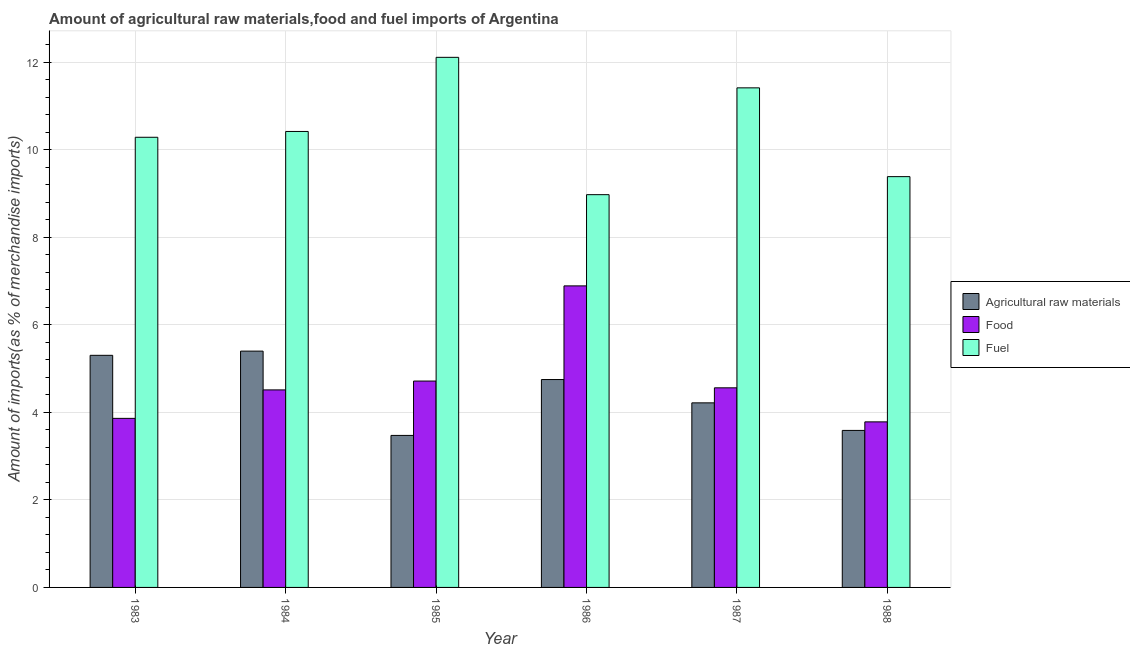Are the number of bars per tick equal to the number of legend labels?
Make the answer very short. Yes. Are the number of bars on each tick of the X-axis equal?
Give a very brief answer. Yes. How many bars are there on the 5th tick from the left?
Keep it short and to the point. 3. What is the percentage of food imports in 1983?
Provide a short and direct response. 3.86. Across all years, what is the maximum percentage of raw materials imports?
Offer a very short reply. 5.4. Across all years, what is the minimum percentage of fuel imports?
Offer a very short reply. 8.98. In which year was the percentage of fuel imports maximum?
Make the answer very short. 1985. What is the total percentage of fuel imports in the graph?
Offer a very short reply. 62.61. What is the difference between the percentage of fuel imports in 1987 and that in 1988?
Give a very brief answer. 2.03. What is the difference between the percentage of fuel imports in 1983 and the percentage of raw materials imports in 1986?
Provide a short and direct response. 1.31. What is the average percentage of raw materials imports per year?
Make the answer very short. 4.46. In the year 1984, what is the difference between the percentage of raw materials imports and percentage of food imports?
Ensure brevity in your answer.  0. What is the ratio of the percentage of food imports in 1983 to that in 1985?
Keep it short and to the point. 0.82. What is the difference between the highest and the second highest percentage of fuel imports?
Keep it short and to the point. 0.7. What is the difference between the highest and the lowest percentage of fuel imports?
Provide a succinct answer. 3.14. In how many years, is the percentage of food imports greater than the average percentage of food imports taken over all years?
Offer a terse response. 1. Is the sum of the percentage of food imports in 1984 and 1988 greater than the maximum percentage of fuel imports across all years?
Provide a succinct answer. Yes. What does the 1st bar from the left in 1986 represents?
Your response must be concise. Agricultural raw materials. What does the 1st bar from the right in 1988 represents?
Provide a short and direct response. Fuel. What is the difference between two consecutive major ticks on the Y-axis?
Your answer should be compact. 2. Are the values on the major ticks of Y-axis written in scientific E-notation?
Ensure brevity in your answer.  No. Does the graph contain any zero values?
Provide a succinct answer. No. Does the graph contain grids?
Make the answer very short. Yes. Where does the legend appear in the graph?
Your answer should be compact. Center right. How many legend labels are there?
Offer a terse response. 3. What is the title of the graph?
Provide a succinct answer. Amount of agricultural raw materials,food and fuel imports of Argentina. Does "Natural Gas" appear as one of the legend labels in the graph?
Keep it short and to the point. No. What is the label or title of the X-axis?
Your response must be concise. Year. What is the label or title of the Y-axis?
Offer a terse response. Amount of imports(as % of merchandise imports). What is the Amount of imports(as % of merchandise imports) in Agricultural raw materials in 1983?
Your answer should be very brief. 5.3. What is the Amount of imports(as % of merchandise imports) of Food in 1983?
Make the answer very short. 3.86. What is the Amount of imports(as % of merchandise imports) of Fuel in 1983?
Give a very brief answer. 10.29. What is the Amount of imports(as % of merchandise imports) in Agricultural raw materials in 1984?
Provide a succinct answer. 5.4. What is the Amount of imports(as % of merchandise imports) of Food in 1984?
Your answer should be compact. 4.51. What is the Amount of imports(as % of merchandise imports) of Fuel in 1984?
Make the answer very short. 10.42. What is the Amount of imports(as % of merchandise imports) in Agricultural raw materials in 1985?
Give a very brief answer. 3.47. What is the Amount of imports(as % of merchandise imports) of Food in 1985?
Provide a succinct answer. 4.72. What is the Amount of imports(as % of merchandise imports) of Fuel in 1985?
Provide a succinct answer. 12.12. What is the Amount of imports(as % of merchandise imports) in Agricultural raw materials in 1986?
Your response must be concise. 4.75. What is the Amount of imports(as % of merchandise imports) of Food in 1986?
Ensure brevity in your answer.  6.89. What is the Amount of imports(as % of merchandise imports) of Fuel in 1986?
Your answer should be compact. 8.98. What is the Amount of imports(as % of merchandise imports) of Agricultural raw materials in 1987?
Your answer should be compact. 4.22. What is the Amount of imports(as % of merchandise imports) of Food in 1987?
Offer a very short reply. 4.56. What is the Amount of imports(as % of merchandise imports) of Fuel in 1987?
Keep it short and to the point. 11.42. What is the Amount of imports(as % of merchandise imports) of Agricultural raw materials in 1988?
Your answer should be compact. 3.59. What is the Amount of imports(as % of merchandise imports) in Food in 1988?
Offer a terse response. 3.78. What is the Amount of imports(as % of merchandise imports) of Fuel in 1988?
Ensure brevity in your answer.  9.39. Across all years, what is the maximum Amount of imports(as % of merchandise imports) of Agricultural raw materials?
Offer a very short reply. 5.4. Across all years, what is the maximum Amount of imports(as % of merchandise imports) in Food?
Your response must be concise. 6.89. Across all years, what is the maximum Amount of imports(as % of merchandise imports) of Fuel?
Make the answer very short. 12.12. Across all years, what is the minimum Amount of imports(as % of merchandise imports) in Agricultural raw materials?
Provide a short and direct response. 3.47. Across all years, what is the minimum Amount of imports(as % of merchandise imports) of Food?
Your response must be concise. 3.78. Across all years, what is the minimum Amount of imports(as % of merchandise imports) of Fuel?
Your answer should be compact. 8.98. What is the total Amount of imports(as % of merchandise imports) in Agricultural raw materials in the graph?
Keep it short and to the point. 26.74. What is the total Amount of imports(as % of merchandise imports) in Food in the graph?
Give a very brief answer. 28.33. What is the total Amount of imports(as % of merchandise imports) of Fuel in the graph?
Give a very brief answer. 62.61. What is the difference between the Amount of imports(as % of merchandise imports) of Agricultural raw materials in 1983 and that in 1984?
Give a very brief answer. -0.1. What is the difference between the Amount of imports(as % of merchandise imports) in Food in 1983 and that in 1984?
Keep it short and to the point. -0.65. What is the difference between the Amount of imports(as % of merchandise imports) of Fuel in 1983 and that in 1984?
Provide a succinct answer. -0.13. What is the difference between the Amount of imports(as % of merchandise imports) in Agricultural raw materials in 1983 and that in 1985?
Your answer should be compact. 1.83. What is the difference between the Amount of imports(as % of merchandise imports) in Food in 1983 and that in 1985?
Provide a succinct answer. -0.85. What is the difference between the Amount of imports(as % of merchandise imports) in Fuel in 1983 and that in 1985?
Make the answer very short. -1.83. What is the difference between the Amount of imports(as % of merchandise imports) of Agricultural raw materials in 1983 and that in 1986?
Your answer should be very brief. 0.55. What is the difference between the Amount of imports(as % of merchandise imports) of Food in 1983 and that in 1986?
Your answer should be very brief. -3.03. What is the difference between the Amount of imports(as % of merchandise imports) of Fuel in 1983 and that in 1986?
Your response must be concise. 1.31. What is the difference between the Amount of imports(as % of merchandise imports) in Agricultural raw materials in 1983 and that in 1987?
Your answer should be compact. 1.09. What is the difference between the Amount of imports(as % of merchandise imports) of Food in 1983 and that in 1987?
Make the answer very short. -0.7. What is the difference between the Amount of imports(as % of merchandise imports) of Fuel in 1983 and that in 1987?
Keep it short and to the point. -1.13. What is the difference between the Amount of imports(as % of merchandise imports) of Agricultural raw materials in 1983 and that in 1988?
Provide a short and direct response. 1.72. What is the difference between the Amount of imports(as % of merchandise imports) in Food in 1983 and that in 1988?
Your response must be concise. 0.08. What is the difference between the Amount of imports(as % of merchandise imports) in Fuel in 1983 and that in 1988?
Ensure brevity in your answer.  0.9. What is the difference between the Amount of imports(as % of merchandise imports) of Agricultural raw materials in 1984 and that in 1985?
Your answer should be compact. 1.93. What is the difference between the Amount of imports(as % of merchandise imports) in Food in 1984 and that in 1985?
Keep it short and to the point. -0.2. What is the difference between the Amount of imports(as % of merchandise imports) of Fuel in 1984 and that in 1985?
Provide a short and direct response. -1.69. What is the difference between the Amount of imports(as % of merchandise imports) of Agricultural raw materials in 1984 and that in 1986?
Make the answer very short. 0.65. What is the difference between the Amount of imports(as % of merchandise imports) in Food in 1984 and that in 1986?
Your answer should be compact. -2.38. What is the difference between the Amount of imports(as % of merchandise imports) in Fuel in 1984 and that in 1986?
Your answer should be very brief. 1.44. What is the difference between the Amount of imports(as % of merchandise imports) in Agricultural raw materials in 1984 and that in 1987?
Offer a very short reply. 1.18. What is the difference between the Amount of imports(as % of merchandise imports) in Food in 1984 and that in 1987?
Your answer should be very brief. -0.05. What is the difference between the Amount of imports(as % of merchandise imports) in Fuel in 1984 and that in 1987?
Provide a succinct answer. -1. What is the difference between the Amount of imports(as % of merchandise imports) of Agricultural raw materials in 1984 and that in 1988?
Give a very brief answer. 1.81. What is the difference between the Amount of imports(as % of merchandise imports) of Food in 1984 and that in 1988?
Offer a terse response. 0.73. What is the difference between the Amount of imports(as % of merchandise imports) of Fuel in 1984 and that in 1988?
Provide a succinct answer. 1.03. What is the difference between the Amount of imports(as % of merchandise imports) of Agricultural raw materials in 1985 and that in 1986?
Provide a succinct answer. -1.28. What is the difference between the Amount of imports(as % of merchandise imports) in Food in 1985 and that in 1986?
Offer a very short reply. -2.18. What is the difference between the Amount of imports(as % of merchandise imports) in Fuel in 1985 and that in 1986?
Your response must be concise. 3.14. What is the difference between the Amount of imports(as % of merchandise imports) in Agricultural raw materials in 1985 and that in 1987?
Give a very brief answer. -0.74. What is the difference between the Amount of imports(as % of merchandise imports) in Food in 1985 and that in 1987?
Offer a terse response. 0.15. What is the difference between the Amount of imports(as % of merchandise imports) in Fuel in 1985 and that in 1987?
Your response must be concise. 0.7. What is the difference between the Amount of imports(as % of merchandise imports) of Agricultural raw materials in 1985 and that in 1988?
Offer a very short reply. -0.11. What is the difference between the Amount of imports(as % of merchandise imports) in Food in 1985 and that in 1988?
Make the answer very short. 0.93. What is the difference between the Amount of imports(as % of merchandise imports) of Fuel in 1985 and that in 1988?
Offer a terse response. 2.73. What is the difference between the Amount of imports(as % of merchandise imports) in Agricultural raw materials in 1986 and that in 1987?
Give a very brief answer. 0.53. What is the difference between the Amount of imports(as % of merchandise imports) of Food in 1986 and that in 1987?
Your response must be concise. 2.33. What is the difference between the Amount of imports(as % of merchandise imports) of Fuel in 1986 and that in 1987?
Your response must be concise. -2.44. What is the difference between the Amount of imports(as % of merchandise imports) of Agricultural raw materials in 1986 and that in 1988?
Your answer should be very brief. 1.16. What is the difference between the Amount of imports(as % of merchandise imports) of Food in 1986 and that in 1988?
Ensure brevity in your answer.  3.11. What is the difference between the Amount of imports(as % of merchandise imports) in Fuel in 1986 and that in 1988?
Offer a very short reply. -0.41. What is the difference between the Amount of imports(as % of merchandise imports) of Agricultural raw materials in 1987 and that in 1988?
Provide a succinct answer. 0.63. What is the difference between the Amount of imports(as % of merchandise imports) in Food in 1987 and that in 1988?
Provide a short and direct response. 0.78. What is the difference between the Amount of imports(as % of merchandise imports) in Fuel in 1987 and that in 1988?
Provide a short and direct response. 2.03. What is the difference between the Amount of imports(as % of merchandise imports) in Agricultural raw materials in 1983 and the Amount of imports(as % of merchandise imports) in Food in 1984?
Your answer should be compact. 0.79. What is the difference between the Amount of imports(as % of merchandise imports) in Agricultural raw materials in 1983 and the Amount of imports(as % of merchandise imports) in Fuel in 1984?
Provide a succinct answer. -5.12. What is the difference between the Amount of imports(as % of merchandise imports) of Food in 1983 and the Amount of imports(as % of merchandise imports) of Fuel in 1984?
Make the answer very short. -6.56. What is the difference between the Amount of imports(as % of merchandise imports) of Agricultural raw materials in 1983 and the Amount of imports(as % of merchandise imports) of Food in 1985?
Your response must be concise. 0.59. What is the difference between the Amount of imports(as % of merchandise imports) in Agricultural raw materials in 1983 and the Amount of imports(as % of merchandise imports) in Fuel in 1985?
Give a very brief answer. -6.81. What is the difference between the Amount of imports(as % of merchandise imports) in Food in 1983 and the Amount of imports(as % of merchandise imports) in Fuel in 1985?
Offer a terse response. -8.25. What is the difference between the Amount of imports(as % of merchandise imports) of Agricultural raw materials in 1983 and the Amount of imports(as % of merchandise imports) of Food in 1986?
Your answer should be compact. -1.59. What is the difference between the Amount of imports(as % of merchandise imports) in Agricultural raw materials in 1983 and the Amount of imports(as % of merchandise imports) in Fuel in 1986?
Ensure brevity in your answer.  -3.67. What is the difference between the Amount of imports(as % of merchandise imports) of Food in 1983 and the Amount of imports(as % of merchandise imports) of Fuel in 1986?
Provide a succinct answer. -5.11. What is the difference between the Amount of imports(as % of merchandise imports) of Agricultural raw materials in 1983 and the Amount of imports(as % of merchandise imports) of Food in 1987?
Keep it short and to the point. 0.74. What is the difference between the Amount of imports(as % of merchandise imports) of Agricultural raw materials in 1983 and the Amount of imports(as % of merchandise imports) of Fuel in 1987?
Give a very brief answer. -6.11. What is the difference between the Amount of imports(as % of merchandise imports) of Food in 1983 and the Amount of imports(as % of merchandise imports) of Fuel in 1987?
Make the answer very short. -7.55. What is the difference between the Amount of imports(as % of merchandise imports) in Agricultural raw materials in 1983 and the Amount of imports(as % of merchandise imports) in Food in 1988?
Ensure brevity in your answer.  1.52. What is the difference between the Amount of imports(as % of merchandise imports) in Agricultural raw materials in 1983 and the Amount of imports(as % of merchandise imports) in Fuel in 1988?
Offer a terse response. -4.08. What is the difference between the Amount of imports(as % of merchandise imports) of Food in 1983 and the Amount of imports(as % of merchandise imports) of Fuel in 1988?
Keep it short and to the point. -5.53. What is the difference between the Amount of imports(as % of merchandise imports) of Agricultural raw materials in 1984 and the Amount of imports(as % of merchandise imports) of Food in 1985?
Give a very brief answer. 0.68. What is the difference between the Amount of imports(as % of merchandise imports) in Agricultural raw materials in 1984 and the Amount of imports(as % of merchandise imports) in Fuel in 1985?
Provide a short and direct response. -6.71. What is the difference between the Amount of imports(as % of merchandise imports) in Food in 1984 and the Amount of imports(as % of merchandise imports) in Fuel in 1985?
Provide a short and direct response. -7.6. What is the difference between the Amount of imports(as % of merchandise imports) in Agricultural raw materials in 1984 and the Amount of imports(as % of merchandise imports) in Food in 1986?
Ensure brevity in your answer.  -1.49. What is the difference between the Amount of imports(as % of merchandise imports) in Agricultural raw materials in 1984 and the Amount of imports(as % of merchandise imports) in Fuel in 1986?
Your answer should be compact. -3.58. What is the difference between the Amount of imports(as % of merchandise imports) in Food in 1984 and the Amount of imports(as % of merchandise imports) in Fuel in 1986?
Give a very brief answer. -4.46. What is the difference between the Amount of imports(as % of merchandise imports) in Agricultural raw materials in 1984 and the Amount of imports(as % of merchandise imports) in Food in 1987?
Your answer should be compact. 0.84. What is the difference between the Amount of imports(as % of merchandise imports) in Agricultural raw materials in 1984 and the Amount of imports(as % of merchandise imports) in Fuel in 1987?
Your answer should be very brief. -6.02. What is the difference between the Amount of imports(as % of merchandise imports) in Food in 1984 and the Amount of imports(as % of merchandise imports) in Fuel in 1987?
Ensure brevity in your answer.  -6.9. What is the difference between the Amount of imports(as % of merchandise imports) of Agricultural raw materials in 1984 and the Amount of imports(as % of merchandise imports) of Food in 1988?
Provide a succinct answer. 1.62. What is the difference between the Amount of imports(as % of merchandise imports) in Agricultural raw materials in 1984 and the Amount of imports(as % of merchandise imports) in Fuel in 1988?
Offer a terse response. -3.99. What is the difference between the Amount of imports(as % of merchandise imports) of Food in 1984 and the Amount of imports(as % of merchandise imports) of Fuel in 1988?
Your response must be concise. -4.87. What is the difference between the Amount of imports(as % of merchandise imports) in Agricultural raw materials in 1985 and the Amount of imports(as % of merchandise imports) in Food in 1986?
Offer a terse response. -3.42. What is the difference between the Amount of imports(as % of merchandise imports) of Agricultural raw materials in 1985 and the Amount of imports(as % of merchandise imports) of Fuel in 1986?
Provide a short and direct response. -5.5. What is the difference between the Amount of imports(as % of merchandise imports) of Food in 1985 and the Amount of imports(as % of merchandise imports) of Fuel in 1986?
Give a very brief answer. -4.26. What is the difference between the Amount of imports(as % of merchandise imports) in Agricultural raw materials in 1985 and the Amount of imports(as % of merchandise imports) in Food in 1987?
Your response must be concise. -1.09. What is the difference between the Amount of imports(as % of merchandise imports) in Agricultural raw materials in 1985 and the Amount of imports(as % of merchandise imports) in Fuel in 1987?
Your answer should be compact. -7.94. What is the difference between the Amount of imports(as % of merchandise imports) in Food in 1985 and the Amount of imports(as % of merchandise imports) in Fuel in 1987?
Offer a very short reply. -6.7. What is the difference between the Amount of imports(as % of merchandise imports) of Agricultural raw materials in 1985 and the Amount of imports(as % of merchandise imports) of Food in 1988?
Keep it short and to the point. -0.31. What is the difference between the Amount of imports(as % of merchandise imports) of Agricultural raw materials in 1985 and the Amount of imports(as % of merchandise imports) of Fuel in 1988?
Your answer should be compact. -5.91. What is the difference between the Amount of imports(as % of merchandise imports) of Food in 1985 and the Amount of imports(as % of merchandise imports) of Fuel in 1988?
Keep it short and to the point. -4.67. What is the difference between the Amount of imports(as % of merchandise imports) of Agricultural raw materials in 1986 and the Amount of imports(as % of merchandise imports) of Food in 1987?
Keep it short and to the point. 0.19. What is the difference between the Amount of imports(as % of merchandise imports) of Agricultural raw materials in 1986 and the Amount of imports(as % of merchandise imports) of Fuel in 1987?
Your answer should be very brief. -6.67. What is the difference between the Amount of imports(as % of merchandise imports) in Food in 1986 and the Amount of imports(as % of merchandise imports) in Fuel in 1987?
Give a very brief answer. -4.53. What is the difference between the Amount of imports(as % of merchandise imports) of Agricultural raw materials in 1986 and the Amount of imports(as % of merchandise imports) of Food in 1988?
Offer a very short reply. 0.97. What is the difference between the Amount of imports(as % of merchandise imports) in Agricultural raw materials in 1986 and the Amount of imports(as % of merchandise imports) in Fuel in 1988?
Keep it short and to the point. -4.64. What is the difference between the Amount of imports(as % of merchandise imports) in Food in 1986 and the Amount of imports(as % of merchandise imports) in Fuel in 1988?
Give a very brief answer. -2.5. What is the difference between the Amount of imports(as % of merchandise imports) in Agricultural raw materials in 1987 and the Amount of imports(as % of merchandise imports) in Food in 1988?
Ensure brevity in your answer.  0.43. What is the difference between the Amount of imports(as % of merchandise imports) in Agricultural raw materials in 1987 and the Amount of imports(as % of merchandise imports) in Fuel in 1988?
Make the answer very short. -5.17. What is the difference between the Amount of imports(as % of merchandise imports) of Food in 1987 and the Amount of imports(as % of merchandise imports) of Fuel in 1988?
Your answer should be very brief. -4.83. What is the average Amount of imports(as % of merchandise imports) in Agricultural raw materials per year?
Offer a very short reply. 4.46. What is the average Amount of imports(as % of merchandise imports) in Food per year?
Make the answer very short. 4.72. What is the average Amount of imports(as % of merchandise imports) in Fuel per year?
Ensure brevity in your answer.  10.43. In the year 1983, what is the difference between the Amount of imports(as % of merchandise imports) of Agricultural raw materials and Amount of imports(as % of merchandise imports) of Food?
Provide a succinct answer. 1.44. In the year 1983, what is the difference between the Amount of imports(as % of merchandise imports) of Agricultural raw materials and Amount of imports(as % of merchandise imports) of Fuel?
Make the answer very short. -4.98. In the year 1983, what is the difference between the Amount of imports(as % of merchandise imports) in Food and Amount of imports(as % of merchandise imports) in Fuel?
Offer a terse response. -6.42. In the year 1984, what is the difference between the Amount of imports(as % of merchandise imports) in Agricultural raw materials and Amount of imports(as % of merchandise imports) in Food?
Offer a terse response. 0.89. In the year 1984, what is the difference between the Amount of imports(as % of merchandise imports) in Agricultural raw materials and Amount of imports(as % of merchandise imports) in Fuel?
Provide a short and direct response. -5.02. In the year 1984, what is the difference between the Amount of imports(as % of merchandise imports) of Food and Amount of imports(as % of merchandise imports) of Fuel?
Provide a succinct answer. -5.91. In the year 1985, what is the difference between the Amount of imports(as % of merchandise imports) of Agricultural raw materials and Amount of imports(as % of merchandise imports) of Food?
Offer a terse response. -1.24. In the year 1985, what is the difference between the Amount of imports(as % of merchandise imports) of Agricultural raw materials and Amount of imports(as % of merchandise imports) of Fuel?
Keep it short and to the point. -8.64. In the year 1985, what is the difference between the Amount of imports(as % of merchandise imports) in Food and Amount of imports(as % of merchandise imports) in Fuel?
Your response must be concise. -7.4. In the year 1986, what is the difference between the Amount of imports(as % of merchandise imports) in Agricultural raw materials and Amount of imports(as % of merchandise imports) in Food?
Offer a very short reply. -2.14. In the year 1986, what is the difference between the Amount of imports(as % of merchandise imports) in Agricultural raw materials and Amount of imports(as % of merchandise imports) in Fuel?
Your answer should be very brief. -4.23. In the year 1986, what is the difference between the Amount of imports(as % of merchandise imports) of Food and Amount of imports(as % of merchandise imports) of Fuel?
Make the answer very short. -2.08. In the year 1987, what is the difference between the Amount of imports(as % of merchandise imports) in Agricultural raw materials and Amount of imports(as % of merchandise imports) in Food?
Your answer should be very brief. -0.34. In the year 1987, what is the difference between the Amount of imports(as % of merchandise imports) of Agricultural raw materials and Amount of imports(as % of merchandise imports) of Fuel?
Your response must be concise. -7.2. In the year 1987, what is the difference between the Amount of imports(as % of merchandise imports) in Food and Amount of imports(as % of merchandise imports) in Fuel?
Offer a terse response. -6.86. In the year 1988, what is the difference between the Amount of imports(as % of merchandise imports) of Agricultural raw materials and Amount of imports(as % of merchandise imports) of Food?
Give a very brief answer. -0.2. In the year 1988, what is the difference between the Amount of imports(as % of merchandise imports) in Agricultural raw materials and Amount of imports(as % of merchandise imports) in Fuel?
Your response must be concise. -5.8. In the year 1988, what is the difference between the Amount of imports(as % of merchandise imports) in Food and Amount of imports(as % of merchandise imports) in Fuel?
Ensure brevity in your answer.  -5.6. What is the ratio of the Amount of imports(as % of merchandise imports) of Agricultural raw materials in 1983 to that in 1984?
Your answer should be compact. 0.98. What is the ratio of the Amount of imports(as % of merchandise imports) in Food in 1983 to that in 1984?
Provide a short and direct response. 0.86. What is the ratio of the Amount of imports(as % of merchandise imports) of Fuel in 1983 to that in 1984?
Give a very brief answer. 0.99. What is the ratio of the Amount of imports(as % of merchandise imports) in Agricultural raw materials in 1983 to that in 1985?
Ensure brevity in your answer.  1.53. What is the ratio of the Amount of imports(as % of merchandise imports) in Food in 1983 to that in 1985?
Keep it short and to the point. 0.82. What is the ratio of the Amount of imports(as % of merchandise imports) in Fuel in 1983 to that in 1985?
Offer a terse response. 0.85. What is the ratio of the Amount of imports(as % of merchandise imports) of Agricultural raw materials in 1983 to that in 1986?
Provide a succinct answer. 1.12. What is the ratio of the Amount of imports(as % of merchandise imports) of Food in 1983 to that in 1986?
Keep it short and to the point. 0.56. What is the ratio of the Amount of imports(as % of merchandise imports) of Fuel in 1983 to that in 1986?
Your response must be concise. 1.15. What is the ratio of the Amount of imports(as % of merchandise imports) in Agricultural raw materials in 1983 to that in 1987?
Your answer should be compact. 1.26. What is the ratio of the Amount of imports(as % of merchandise imports) of Food in 1983 to that in 1987?
Give a very brief answer. 0.85. What is the ratio of the Amount of imports(as % of merchandise imports) in Fuel in 1983 to that in 1987?
Offer a very short reply. 0.9. What is the ratio of the Amount of imports(as % of merchandise imports) in Agricultural raw materials in 1983 to that in 1988?
Give a very brief answer. 1.48. What is the ratio of the Amount of imports(as % of merchandise imports) of Food in 1983 to that in 1988?
Ensure brevity in your answer.  1.02. What is the ratio of the Amount of imports(as % of merchandise imports) in Fuel in 1983 to that in 1988?
Your answer should be very brief. 1.1. What is the ratio of the Amount of imports(as % of merchandise imports) of Agricultural raw materials in 1984 to that in 1985?
Offer a terse response. 1.55. What is the ratio of the Amount of imports(as % of merchandise imports) of Food in 1984 to that in 1985?
Make the answer very short. 0.96. What is the ratio of the Amount of imports(as % of merchandise imports) in Fuel in 1984 to that in 1985?
Offer a terse response. 0.86. What is the ratio of the Amount of imports(as % of merchandise imports) of Agricultural raw materials in 1984 to that in 1986?
Make the answer very short. 1.14. What is the ratio of the Amount of imports(as % of merchandise imports) of Food in 1984 to that in 1986?
Make the answer very short. 0.66. What is the ratio of the Amount of imports(as % of merchandise imports) in Fuel in 1984 to that in 1986?
Offer a terse response. 1.16. What is the ratio of the Amount of imports(as % of merchandise imports) of Agricultural raw materials in 1984 to that in 1987?
Your answer should be very brief. 1.28. What is the ratio of the Amount of imports(as % of merchandise imports) in Fuel in 1984 to that in 1987?
Your answer should be compact. 0.91. What is the ratio of the Amount of imports(as % of merchandise imports) in Agricultural raw materials in 1984 to that in 1988?
Provide a succinct answer. 1.5. What is the ratio of the Amount of imports(as % of merchandise imports) in Food in 1984 to that in 1988?
Ensure brevity in your answer.  1.19. What is the ratio of the Amount of imports(as % of merchandise imports) of Fuel in 1984 to that in 1988?
Offer a very short reply. 1.11. What is the ratio of the Amount of imports(as % of merchandise imports) in Agricultural raw materials in 1985 to that in 1986?
Your answer should be very brief. 0.73. What is the ratio of the Amount of imports(as % of merchandise imports) of Food in 1985 to that in 1986?
Your answer should be compact. 0.68. What is the ratio of the Amount of imports(as % of merchandise imports) of Fuel in 1985 to that in 1986?
Your answer should be very brief. 1.35. What is the ratio of the Amount of imports(as % of merchandise imports) of Agricultural raw materials in 1985 to that in 1987?
Give a very brief answer. 0.82. What is the ratio of the Amount of imports(as % of merchandise imports) in Food in 1985 to that in 1987?
Your answer should be compact. 1.03. What is the ratio of the Amount of imports(as % of merchandise imports) in Fuel in 1985 to that in 1987?
Your response must be concise. 1.06. What is the ratio of the Amount of imports(as % of merchandise imports) in Agricultural raw materials in 1985 to that in 1988?
Keep it short and to the point. 0.97. What is the ratio of the Amount of imports(as % of merchandise imports) in Food in 1985 to that in 1988?
Offer a terse response. 1.25. What is the ratio of the Amount of imports(as % of merchandise imports) of Fuel in 1985 to that in 1988?
Make the answer very short. 1.29. What is the ratio of the Amount of imports(as % of merchandise imports) of Agricultural raw materials in 1986 to that in 1987?
Ensure brevity in your answer.  1.13. What is the ratio of the Amount of imports(as % of merchandise imports) of Food in 1986 to that in 1987?
Give a very brief answer. 1.51. What is the ratio of the Amount of imports(as % of merchandise imports) in Fuel in 1986 to that in 1987?
Your answer should be very brief. 0.79. What is the ratio of the Amount of imports(as % of merchandise imports) of Agricultural raw materials in 1986 to that in 1988?
Offer a very short reply. 1.32. What is the ratio of the Amount of imports(as % of merchandise imports) of Food in 1986 to that in 1988?
Offer a very short reply. 1.82. What is the ratio of the Amount of imports(as % of merchandise imports) in Fuel in 1986 to that in 1988?
Your response must be concise. 0.96. What is the ratio of the Amount of imports(as % of merchandise imports) in Agricultural raw materials in 1987 to that in 1988?
Ensure brevity in your answer.  1.18. What is the ratio of the Amount of imports(as % of merchandise imports) in Food in 1987 to that in 1988?
Your answer should be compact. 1.21. What is the ratio of the Amount of imports(as % of merchandise imports) in Fuel in 1987 to that in 1988?
Offer a very short reply. 1.22. What is the difference between the highest and the second highest Amount of imports(as % of merchandise imports) of Agricultural raw materials?
Give a very brief answer. 0.1. What is the difference between the highest and the second highest Amount of imports(as % of merchandise imports) in Food?
Your answer should be compact. 2.18. What is the difference between the highest and the second highest Amount of imports(as % of merchandise imports) in Fuel?
Keep it short and to the point. 0.7. What is the difference between the highest and the lowest Amount of imports(as % of merchandise imports) of Agricultural raw materials?
Your answer should be very brief. 1.93. What is the difference between the highest and the lowest Amount of imports(as % of merchandise imports) of Food?
Your answer should be very brief. 3.11. What is the difference between the highest and the lowest Amount of imports(as % of merchandise imports) in Fuel?
Make the answer very short. 3.14. 